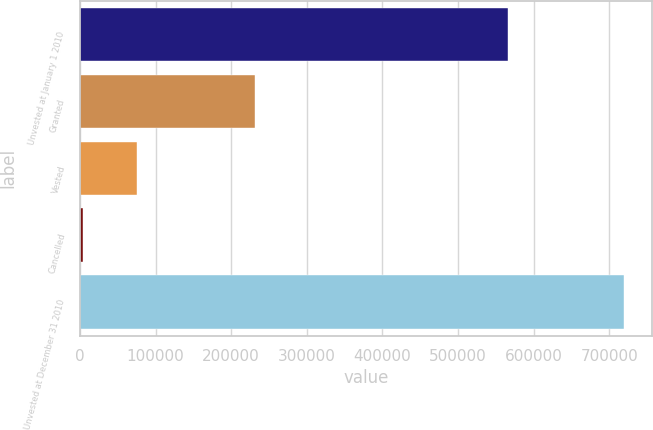Convert chart. <chart><loc_0><loc_0><loc_500><loc_500><bar_chart><fcel>Unvested at January 1 2010<fcel>Granted<fcel>Vested<fcel>Cancelled<fcel>Unvested at December 31 2010<nl><fcel>566449<fcel>231037<fcel>75027<fcel>3366<fcel>719976<nl></chart> 